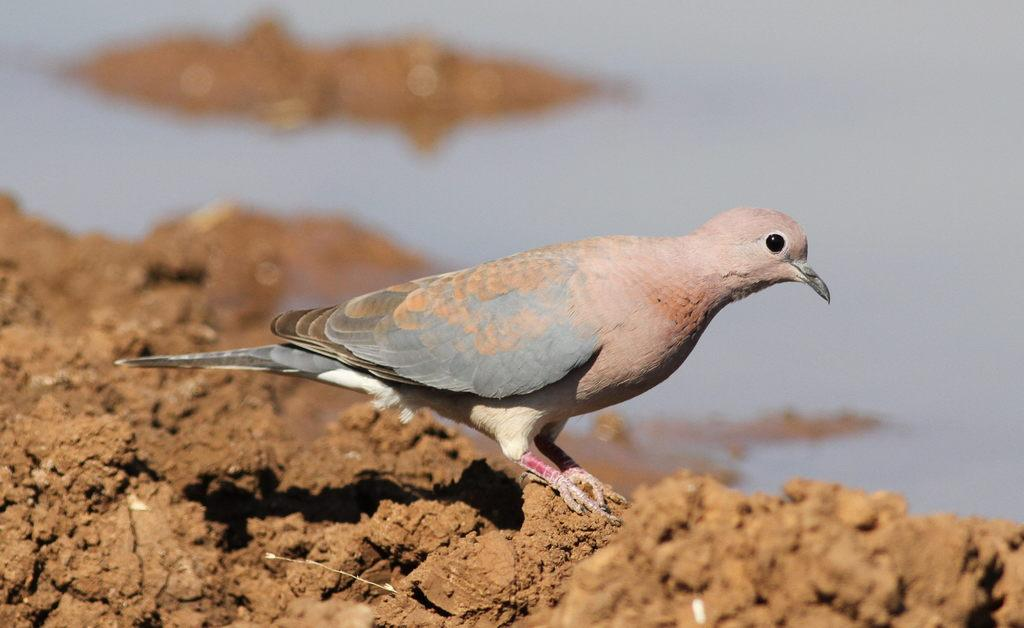What is the main subject in the center of the image? There is a bird in the center of the image. What type of surface is visible at the bottom of the image? There is sand at the bottom of the image. What can be seen in the background of the image? There is a beach in the background of the image. How does the beggar cover their journey to the beach in the image? There is no beggar present in the image, and therefore no journey to cover. 